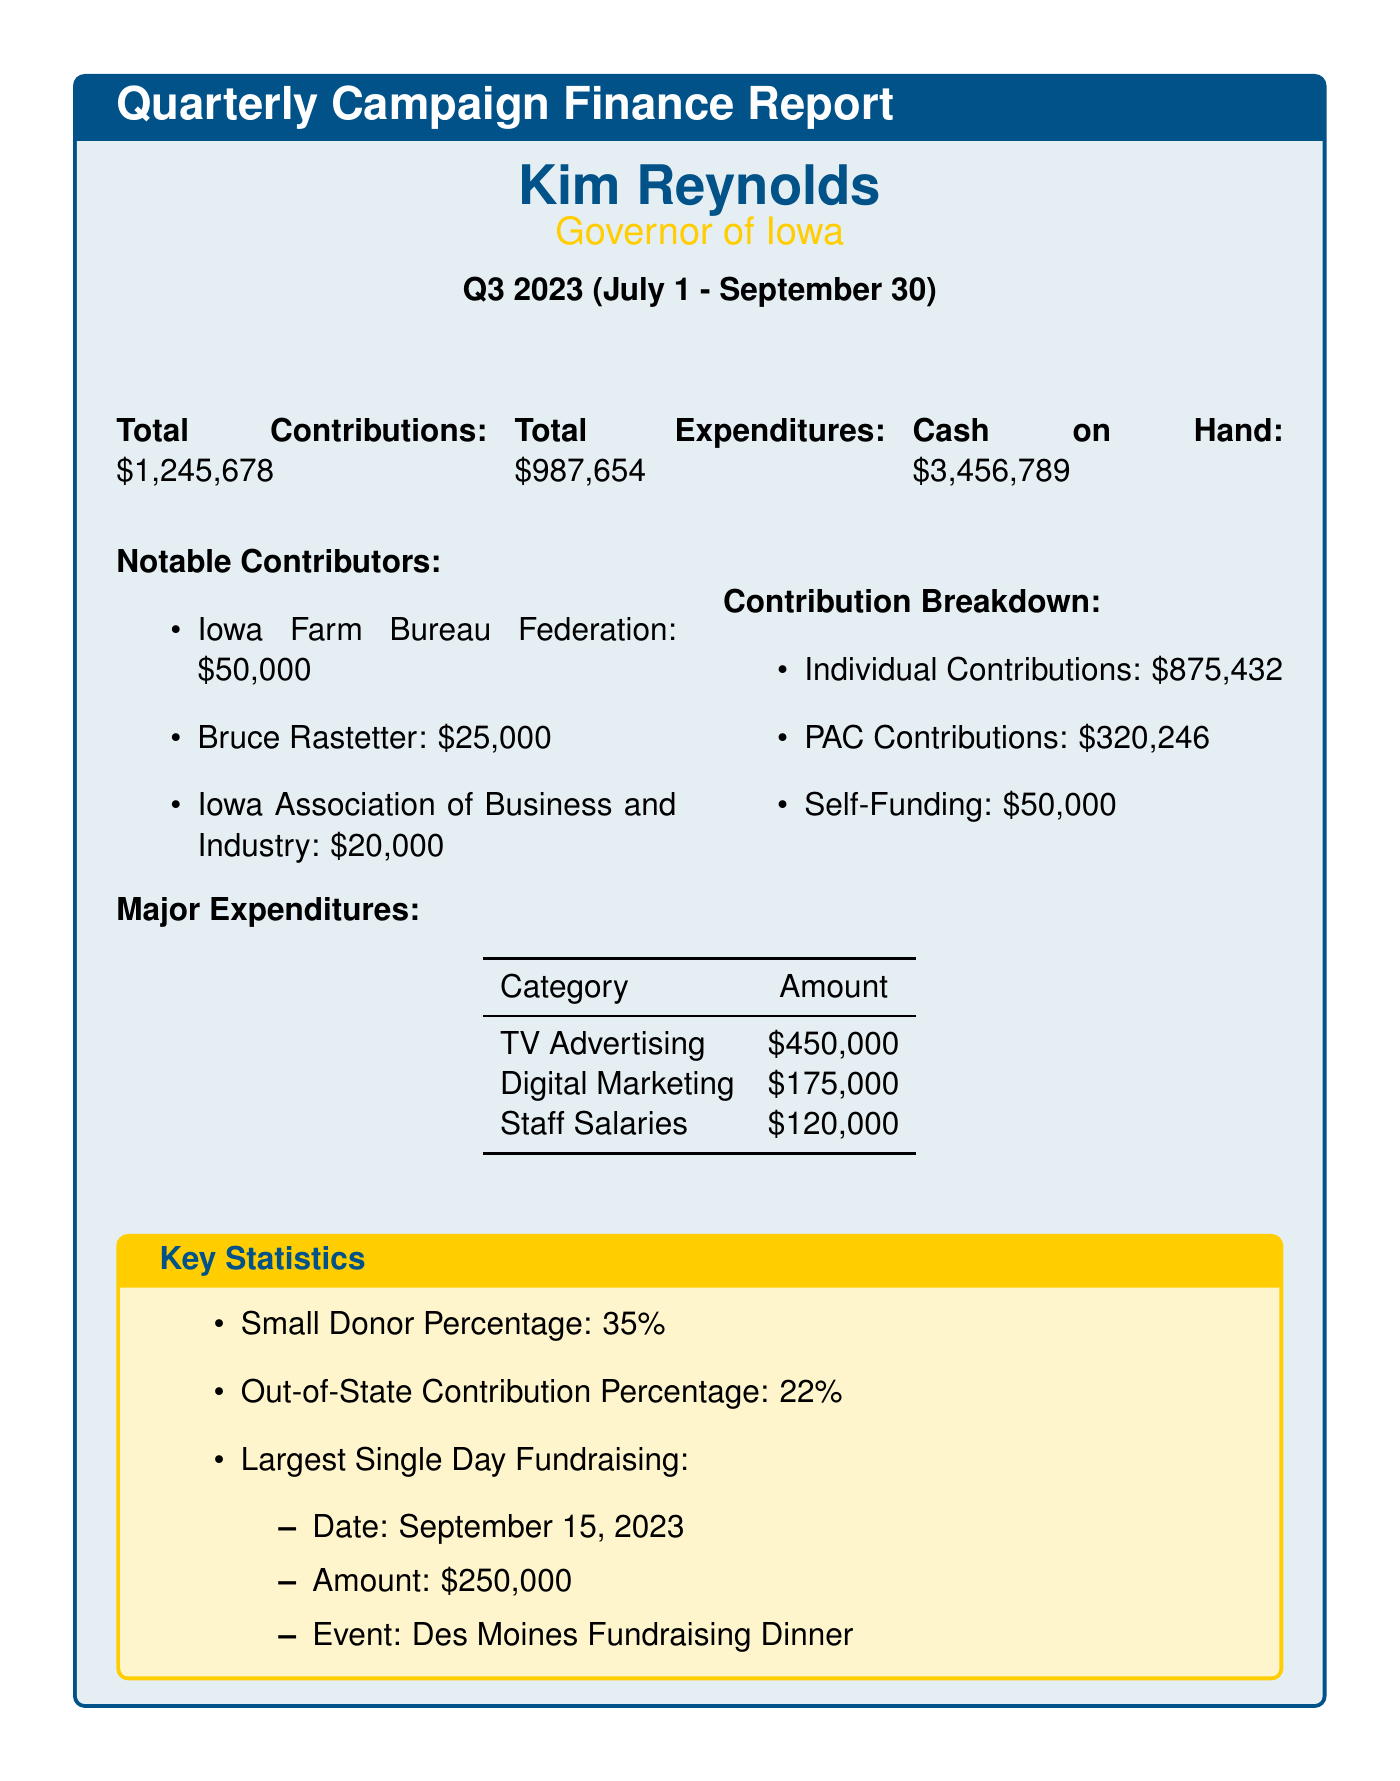What is the total contributions? The total contributions can be found in the document, specifically noted under the relevant section of contributions.
Answer: $1,245,678 Who is the largest single contributor? The largest single contributor can be found in the notable contributors section of the document.
Answer: Iowa Farm Bureau Federation What is the total expenditures? The total expenditures are mentioned in the financial summary of the report.
Answer: $987,654 What percentage of contributions are from small donors? The percentage of small donor contributions is explicitly stated in the key statistics section.
Answer: 35% What was the amount raised during the largest single day fundraising event? This amount is provided in the largest single day fundraising details of the report.
Answer: $250,000 How much was spent on TV advertising? The expenditure for TV advertising is specifically listed under the major expenditures section.
Answer: $450,000 What is the cash on hand? The cash on hand is detailed in the financial summary of the report.
Answer: $3,456,789 What date did the largest single day fundraising occur? The date for the largest single day fundraising is mentioned alongside the fundraising amount in the key statistics section.
Answer: September 15, 2023 What was the total amount of PAC contributions? The total amount of PAC contributions is stated in the contribution breakdown of the report.
Answer: $320,246 